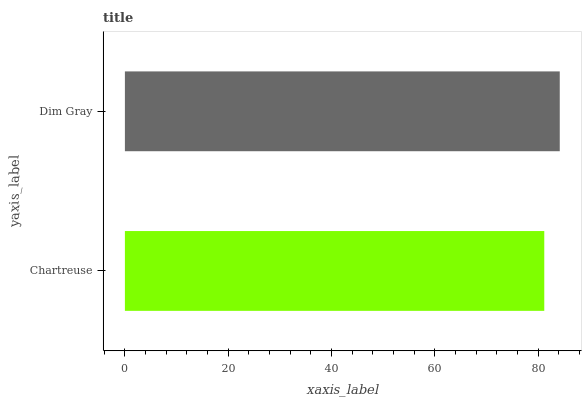Is Chartreuse the minimum?
Answer yes or no. Yes. Is Dim Gray the maximum?
Answer yes or no. Yes. Is Dim Gray the minimum?
Answer yes or no. No. Is Dim Gray greater than Chartreuse?
Answer yes or no. Yes. Is Chartreuse less than Dim Gray?
Answer yes or no. Yes. Is Chartreuse greater than Dim Gray?
Answer yes or no. No. Is Dim Gray less than Chartreuse?
Answer yes or no. No. Is Dim Gray the high median?
Answer yes or no. Yes. Is Chartreuse the low median?
Answer yes or no. Yes. Is Chartreuse the high median?
Answer yes or no. No. Is Dim Gray the low median?
Answer yes or no. No. 